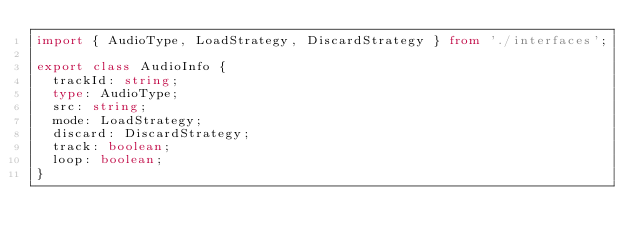Convert code to text. <code><loc_0><loc_0><loc_500><loc_500><_TypeScript_>import { AudioType, LoadStrategy, DiscardStrategy } from './interfaces';

export class AudioInfo {
  trackId: string;
  type: AudioType;
  src: string;
  mode: LoadStrategy;
  discard: DiscardStrategy;
  track: boolean;
  loop: boolean;
}
</code> 